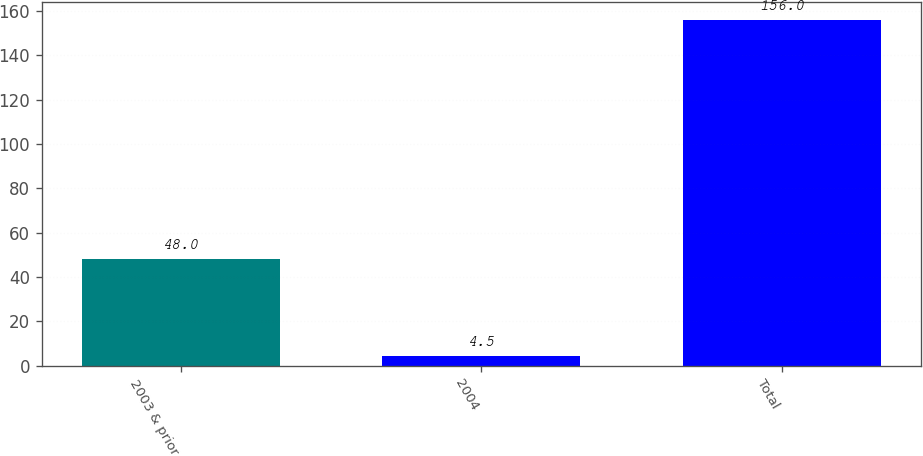Convert chart. <chart><loc_0><loc_0><loc_500><loc_500><bar_chart><fcel>2003 & prior<fcel>2004<fcel>Total<nl><fcel>48<fcel>4.5<fcel>156<nl></chart> 